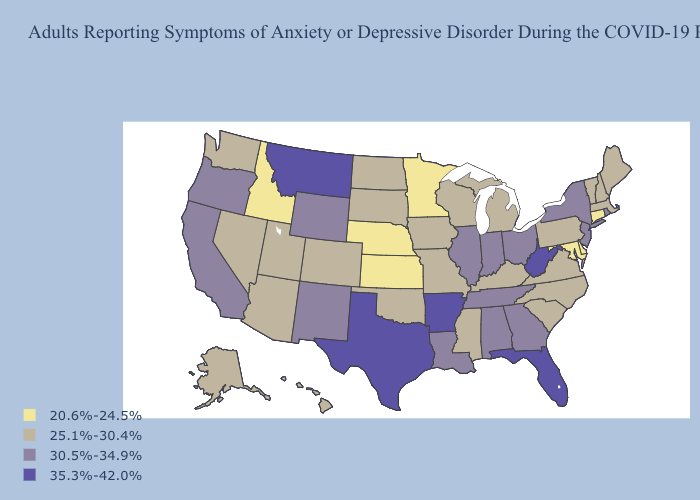What is the value of Montana?
Be succinct. 35.3%-42.0%. Among the states that border Oklahoma , does Kansas have the highest value?
Write a very short answer. No. Among the states that border Arkansas , does Tennessee have the lowest value?
Answer briefly. No. Among the states that border Minnesota , which have the lowest value?
Answer briefly. Iowa, North Dakota, South Dakota, Wisconsin. Does North Carolina have the highest value in the USA?
Be succinct. No. Name the states that have a value in the range 20.6%-24.5%?
Quick response, please. Connecticut, Delaware, Idaho, Kansas, Maryland, Minnesota, Nebraska. Does New Hampshire have a higher value than Idaho?
Write a very short answer. Yes. Does Maine have the highest value in the USA?
Short answer required. No. Among the states that border Illinois , does Indiana have the lowest value?
Concise answer only. No. Name the states that have a value in the range 35.3%-42.0%?
Write a very short answer. Arkansas, Florida, Montana, Texas, West Virginia. What is the value of Arizona?
Concise answer only. 25.1%-30.4%. Does Minnesota have the highest value in the MidWest?
Be succinct. No. Name the states that have a value in the range 25.1%-30.4%?
Write a very short answer. Alaska, Arizona, Colorado, Hawaii, Iowa, Kentucky, Maine, Massachusetts, Michigan, Mississippi, Missouri, Nevada, New Hampshire, North Carolina, North Dakota, Oklahoma, Pennsylvania, South Carolina, South Dakota, Utah, Vermont, Virginia, Washington, Wisconsin. What is the value of Wyoming?
Keep it brief. 30.5%-34.9%. Does Delaware have the lowest value in the South?
Answer briefly. Yes. 